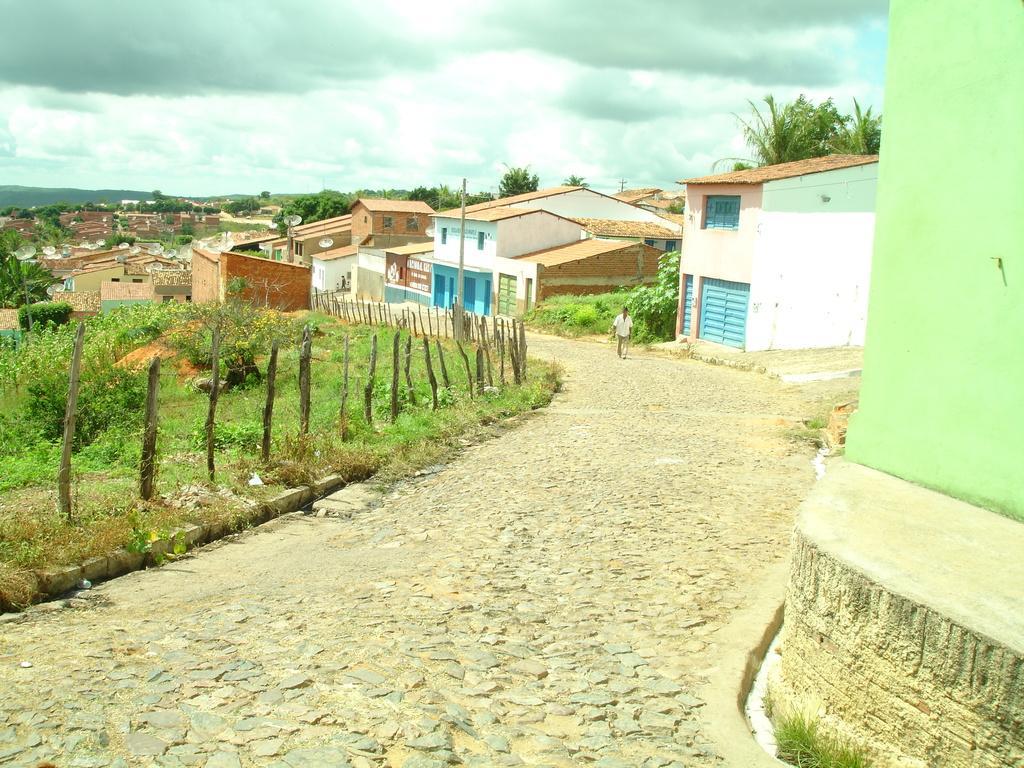Please provide a concise description of this image. In this picture we can see some plants and grass on the left side, on the right side there are some buildings, we can see a person walking in the middle, there is the sky at the top of the picture, at the bottom there are some stones, we can see trees in the background. 